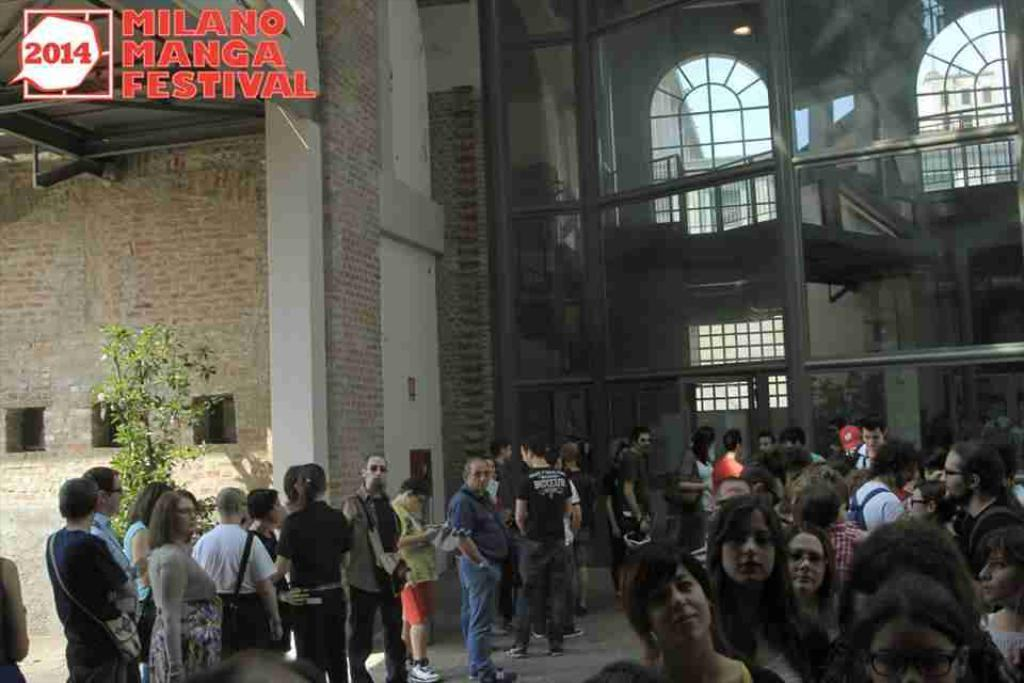What is happening in the image? There are people standing in front of a building. Can you describe the building? The building has windows and doors. Are there any other objects or elements in the image? Yes, there is a plant in the image. Is there any text visible in the image? Yes, there is text visible at the top of the image. What time is displayed on the clock in the image? There is no clock present in the image. What type of prose can be read in the image? There is no prose visible in the image. 